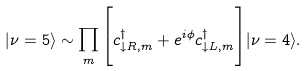Convert formula to latex. <formula><loc_0><loc_0><loc_500><loc_500>| \nu = 5 \rangle \sim \prod _ { m } \Big { [ } c ^ { \dagger } _ { \downarrow R , m } + e ^ { i \phi } c ^ { \dagger } _ { \downarrow L , m } \Big { ] } | \nu = 4 \rangle .</formula> 